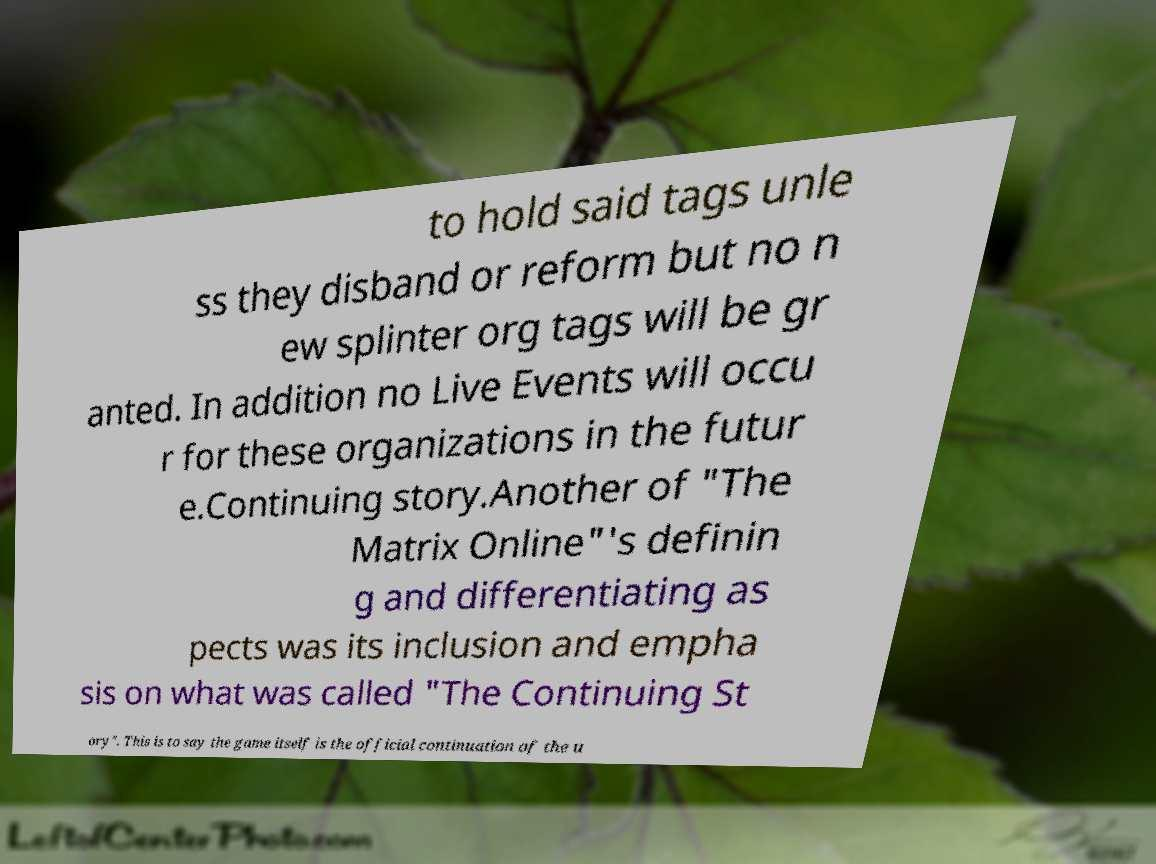What messages or text are displayed in this image? I need them in a readable, typed format. to hold said tags unle ss they disband or reform but no n ew splinter org tags will be gr anted. In addition no Live Events will occu r for these organizations in the futur e.Continuing story.Another of "The Matrix Online"'s definin g and differentiating as pects was its inclusion and empha sis on what was called "The Continuing St ory". This is to say the game itself is the official continuation of the u 